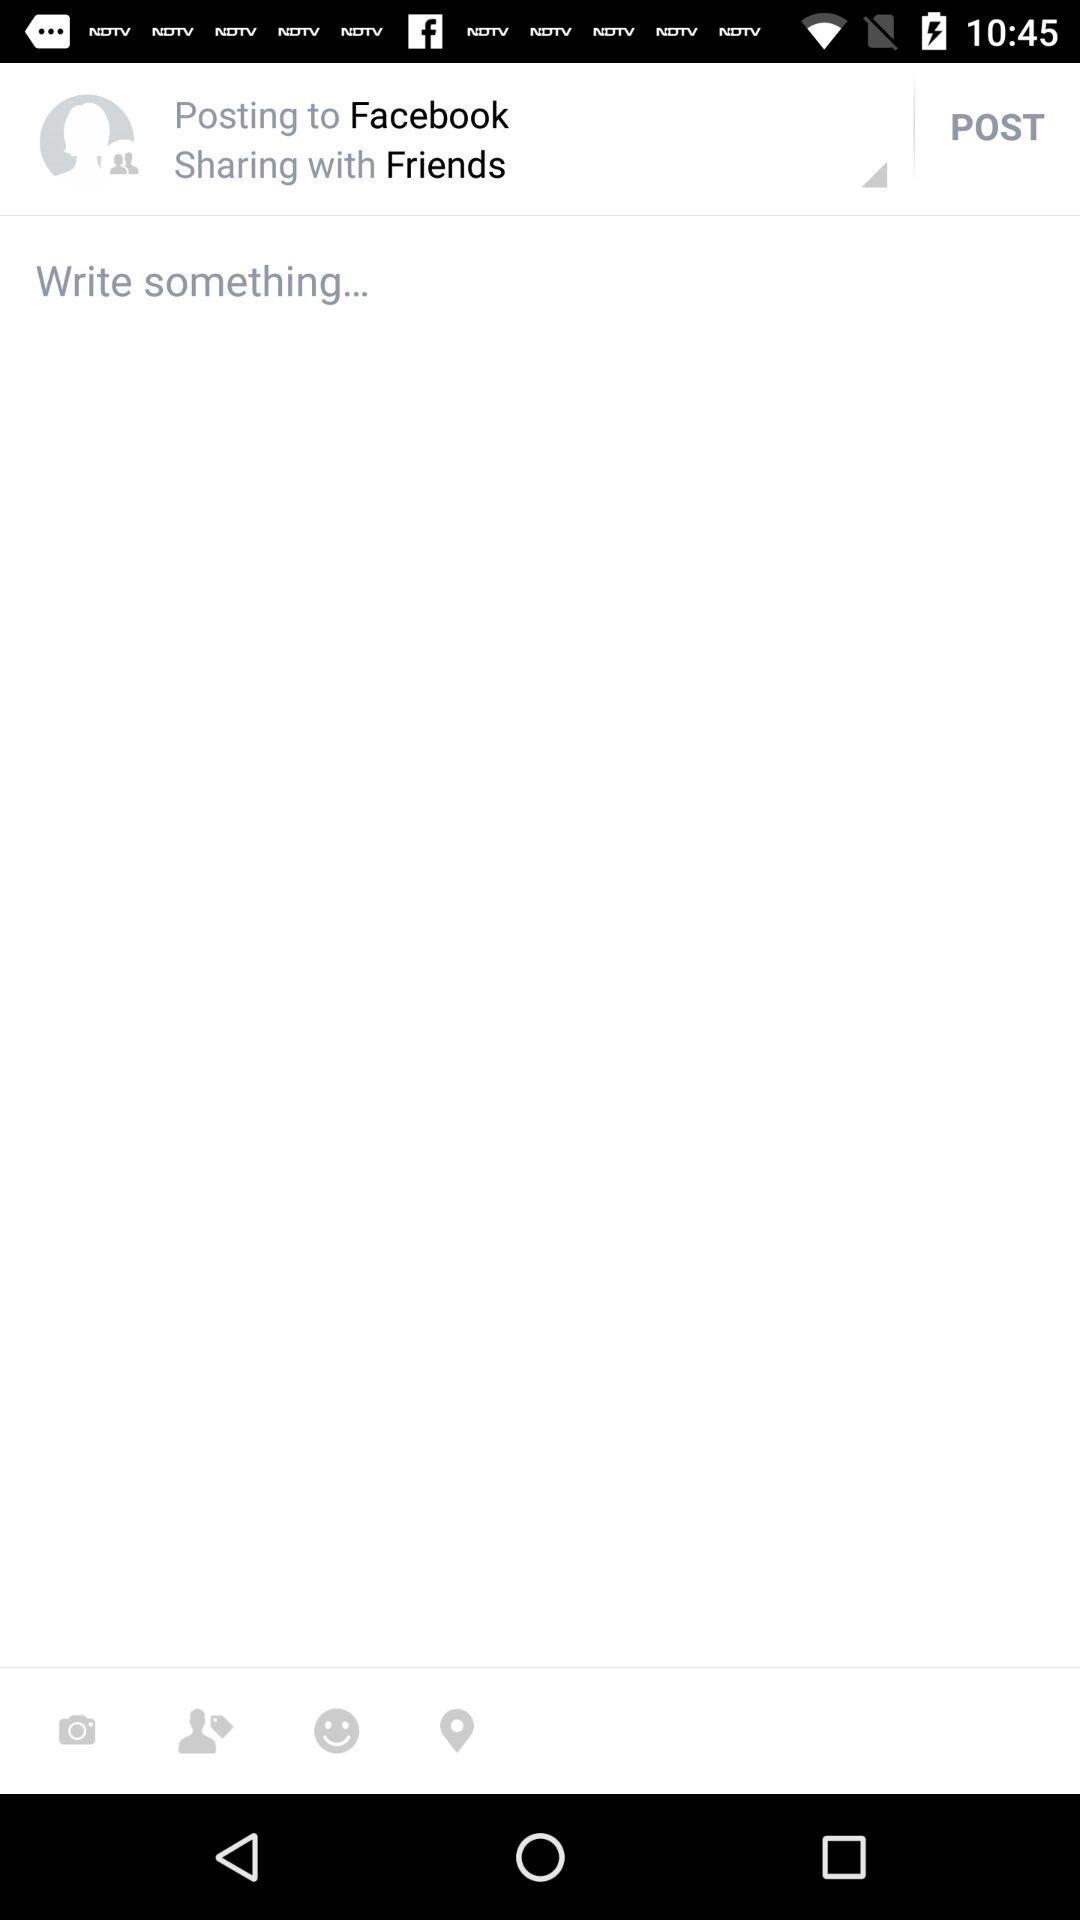On what application is the user posting the post? The user is posting the post on "Facebook". 